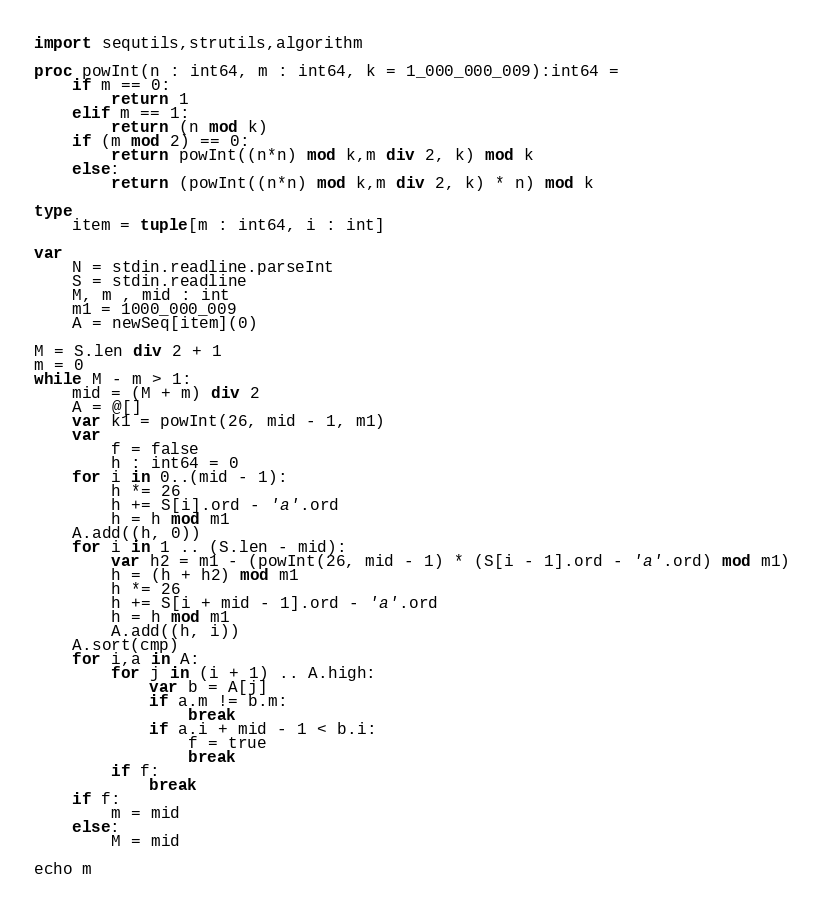Convert code to text. <code><loc_0><loc_0><loc_500><loc_500><_Nim_>import sequtils,strutils,algorithm

proc powInt(n : int64, m : int64, k = 1_000_000_009):int64 =
    if m == 0:
        return 1
    elif m == 1:
        return (n mod k)
    if (m mod 2) == 0:
        return powInt((n*n) mod k,m div 2, k) mod k
    else:
        return (powInt((n*n) mod k,m div 2, k) * n) mod k

type
    item = tuple[m : int64, i : int]

var
    N = stdin.readline.parseInt
    S = stdin.readline
    M, m , mid : int
    m1 = 1000_000_009
    A = newSeq[item](0)
    
M = S.len div 2 + 1
m = 0
while M - m > 1:
    mid = (M + m) div 2
    A = @[]
    var k1 = powInt(26, mid - 1, m1)
    var
        f = false
        h : int64 = 0
    for i in 0..(mid - 1):
        h *= 26
        h += S[i].ord - 'a'.ord
        h = h mod m1
    A.add((h, 0))
    for i in 1 .. (S.len - mid):
        var h2 = m1 - (powInt(26, mid - 1) * (S[i - 1].ord - 'a'.ord) mod m1)
        h = (h + h2) mod m1
        h *= 26
        h += S[i + mid - 1].ord - 'a'.ord
        h = h mod m1
        A.add((h, i))
    A.sort(cmp)
    for i,a in A:
        for j in (i + 1) .. A.high:
            var b = A[j]
            if a.m != b.m:
                break
            if a.i + mid - 1 < b.i:
                f = true
                break
        if f:
            break
    if f:
        m = mid
    else:
        M = mid
    
echo m



</code> 